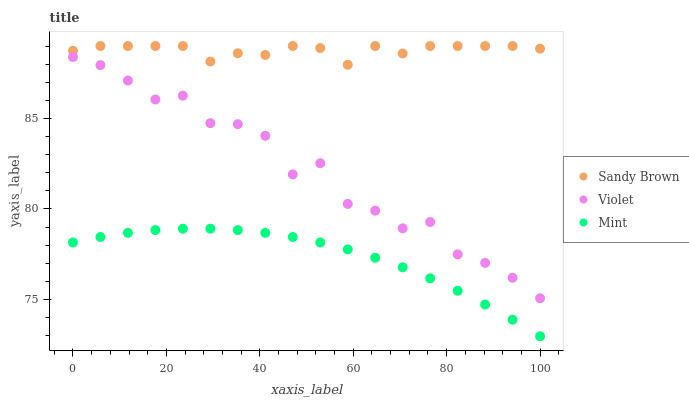Does Mint have the minimum area under the curve?
Answer yes or no. Yes. Does Sandy Brown have the maximum area under the curve?
Answer yes or no. Yes. Does Violet have the minimum area under the curve?
Answer yes or no. No. Does Violet have the maximum area under the curve?
Answer yes or no. No. Is Mint the smoothest?
Answer yes or no. Yes. Is Violet the roughest?
Answer yes or no. Yes. Is Sandy Brown the smoothest?
Answer yes or no. No. Is Sandy Brown the roughest?
Answer yes or no. No. Does Mint have the lowest value?
Answer yes or no. Yes. Does Violet have the lowest value?
Answer yes or no. No. Does Sandy Brown have the highest value?
Answer yes or no. Yes. Does Violet have the highest value?
Answer yes or no. No. Is Violet less than Sandy Brown?
Answer yes or no. Yes. Is Sandy Brown greater than Violet?
Answer yes or no. Yes. Does Violet intersect Sandy Brown?
Answer yes or no. No. 